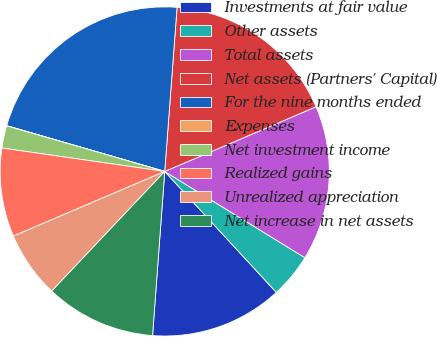<chart> <loc_0><loc_0><loc_500><loc_500><pie_chart><fcel>Investments at fair value<fcel>Other assets<fcel>Total assets<fcel>Net assets (Partners' Capital)<fcel>For the nine months ended<fcel>Expenses<fcel>Net investment income<fcel>Realized gains<fcel>Unrealized appreciation<fcel>Net increase in net assets<nl><fcel>13.04%<fcel>4.36%<fcel>15.21%<fcel>17.38%<fcel>21.71%<fcel>0.02%<fcel>2.19%<fcel>8.7%<fcel>6.53%<fcel>10.87%<nl></chart> 